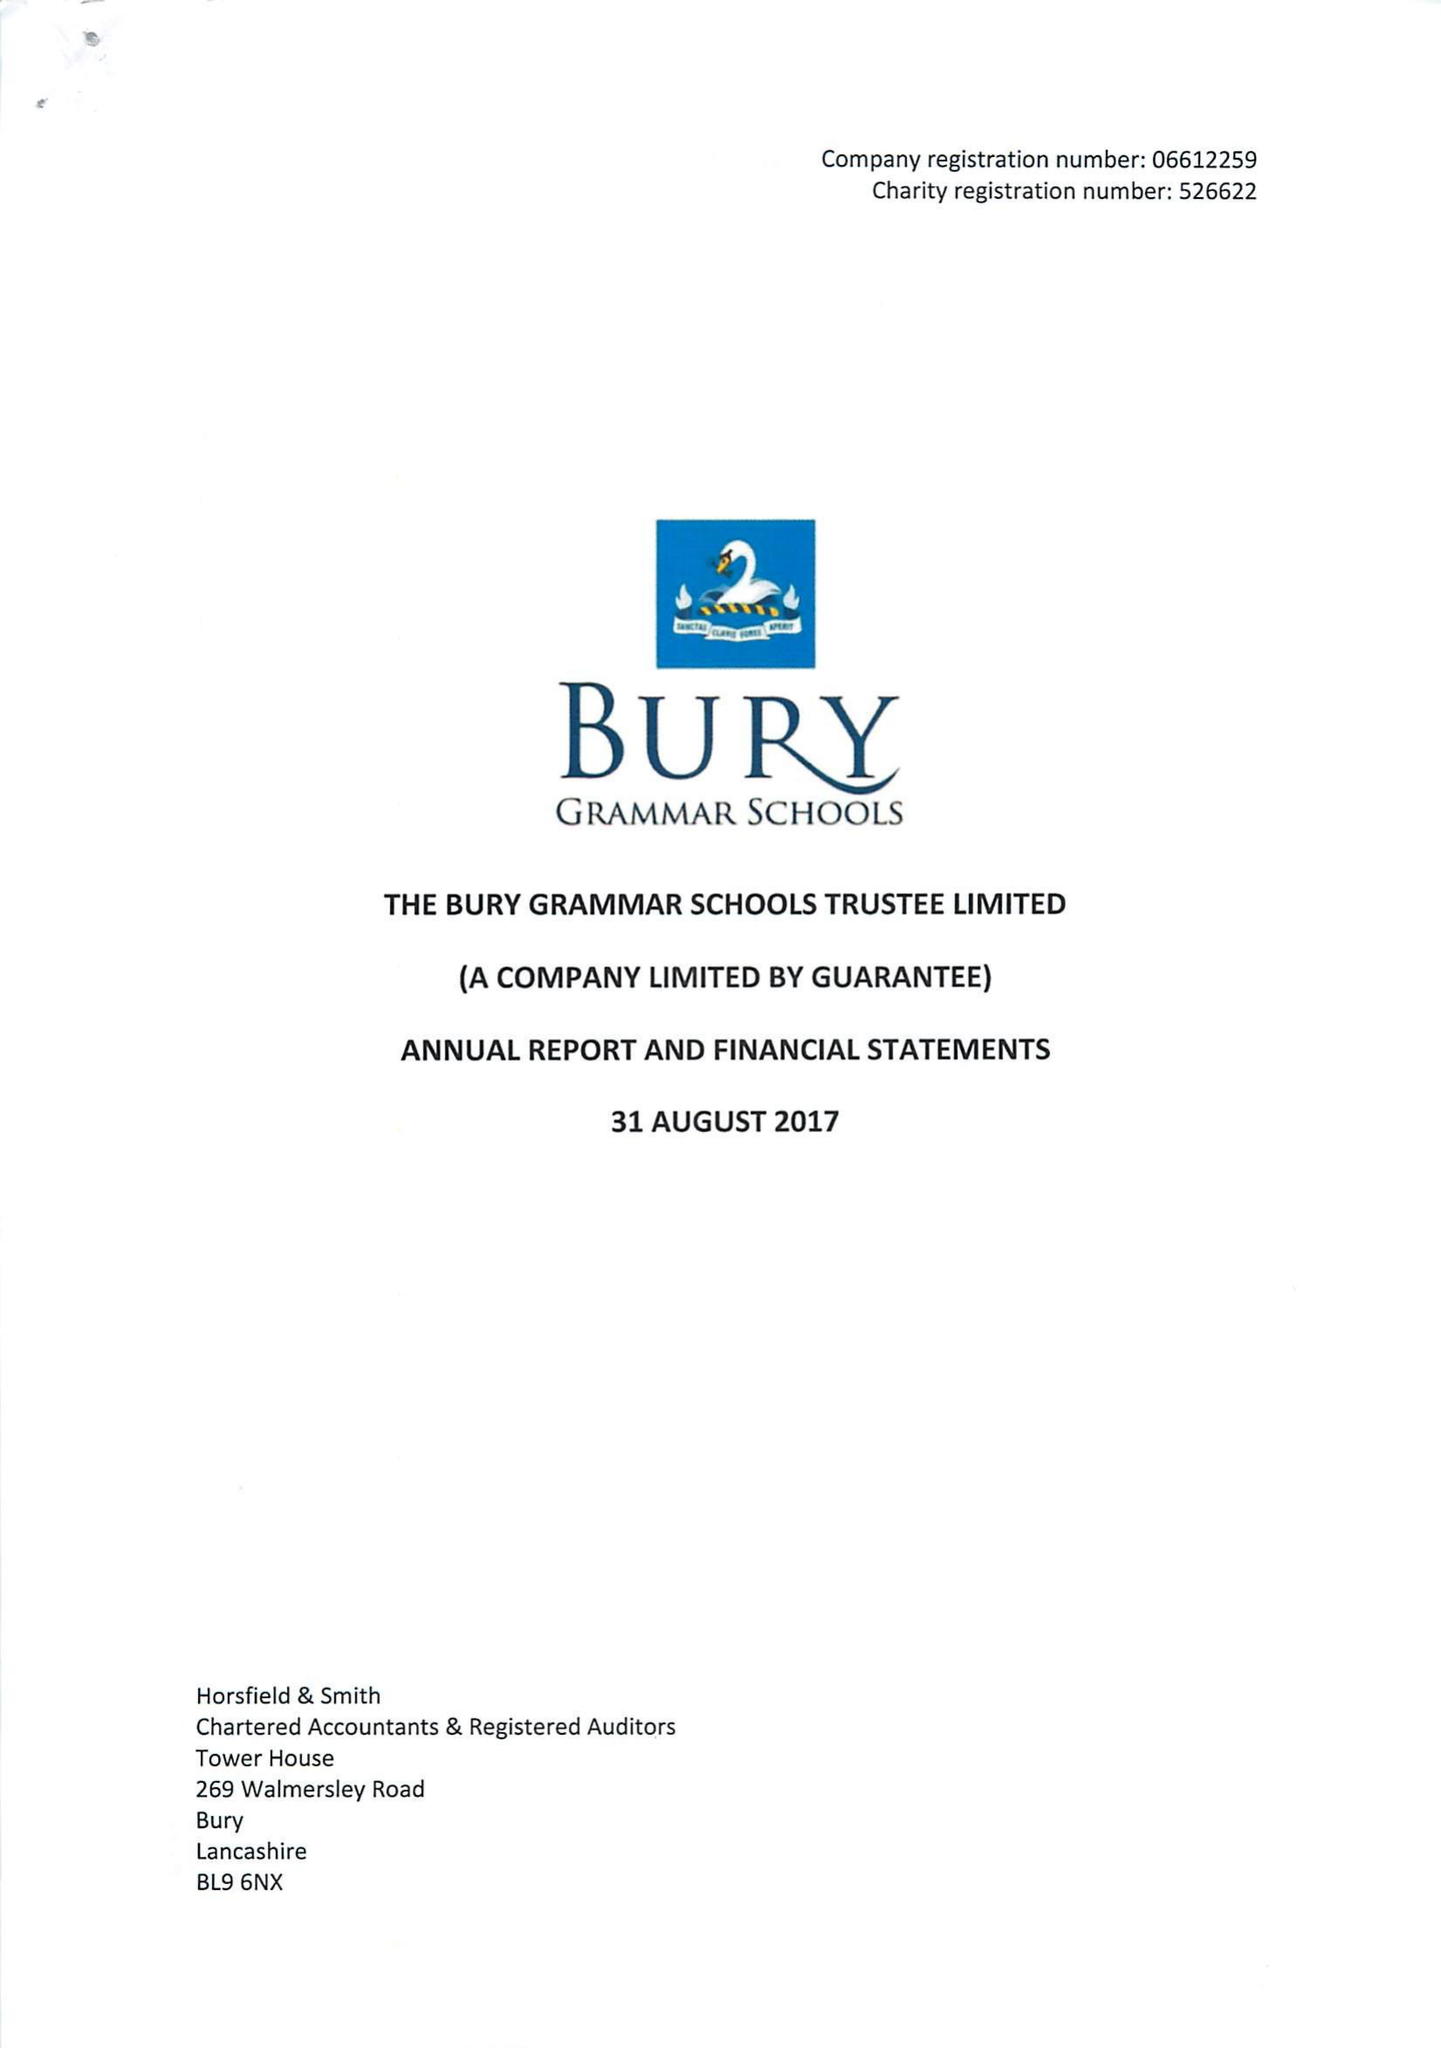What is the value for the charity_name?
Answer the question using a single word or phrase. Bury Grammar Schools Trustee Ltd. 